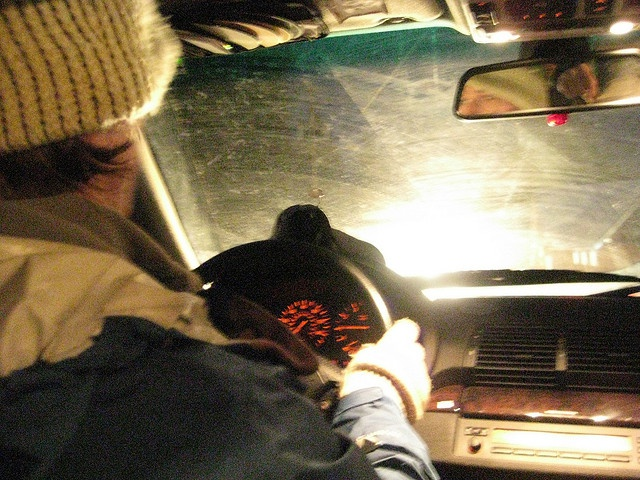Describe the objects in this image and their specific colors. I can see car in black, ivory, and tan tones and people in black, olive, and maroon tones in this image. 